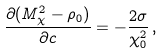<formula> <loc_0><loc_0><loc_500><loc_500>\frac { \partial ( M _ { \chi } ^ { 2 } - \rho _ { 0 } ) } { \partial c } = - \frac { 2 \sigma } { \chi _ { 0 } ^ { 2 } } \, ,</formula> 